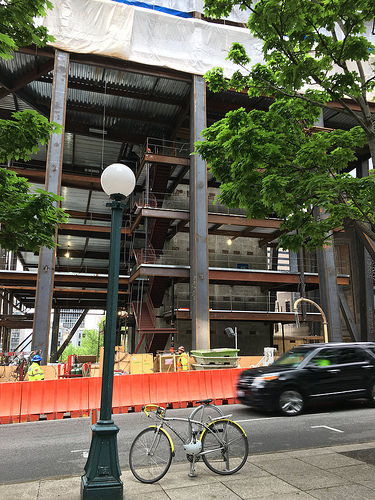<image>
Can you confirm if the bike is behind the pole? Yes. From this viewpoint, the bike is positioned behind the pole, with the pole partially or fully occluding the bike. 